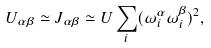<formula> <loc_0><loc_0><loc_500><loc_500>U _ { \alpha \beta } \simeq J _ { \alpha \beta } \simeq { U } \sum _ { i } ( \omega _ { i } ^ { \alpha } \omega _ { i } ^ { \beta } ) ^ { 2 } ,</formula> 